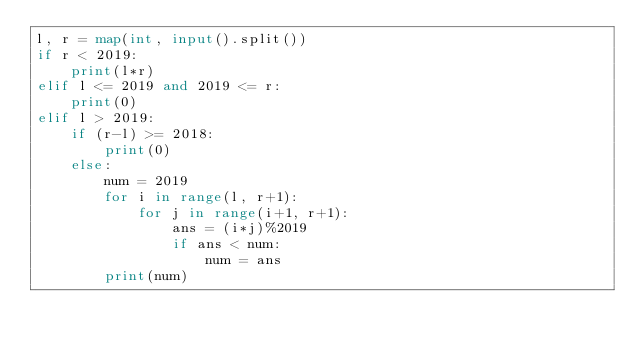<code> <loc_0><loc_0><loc_500><loc_500><_Python_>l, r = map(int, input().split())
if r < 2019:
    print(l*r)
elif l <= 2019 and 2019 <= r:
    print(0)
elif l > 2019:
    if (r-l) >= 2018:
        print(0)
    else:
        num = 2019
        for i in range(l, r+1):
            for j in range(i+1, r+1):
                ans = (i*j)%2019
                if ans < num:
                    num = ans
        print(num)</code> 